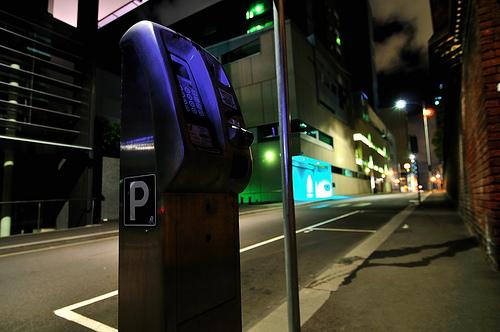What letter is seen?
Write a very short answer. P. What time of day was this picture taken?
Short answer required. Night. Do the stripes on the road need retouching?
Keep it brief. No. 